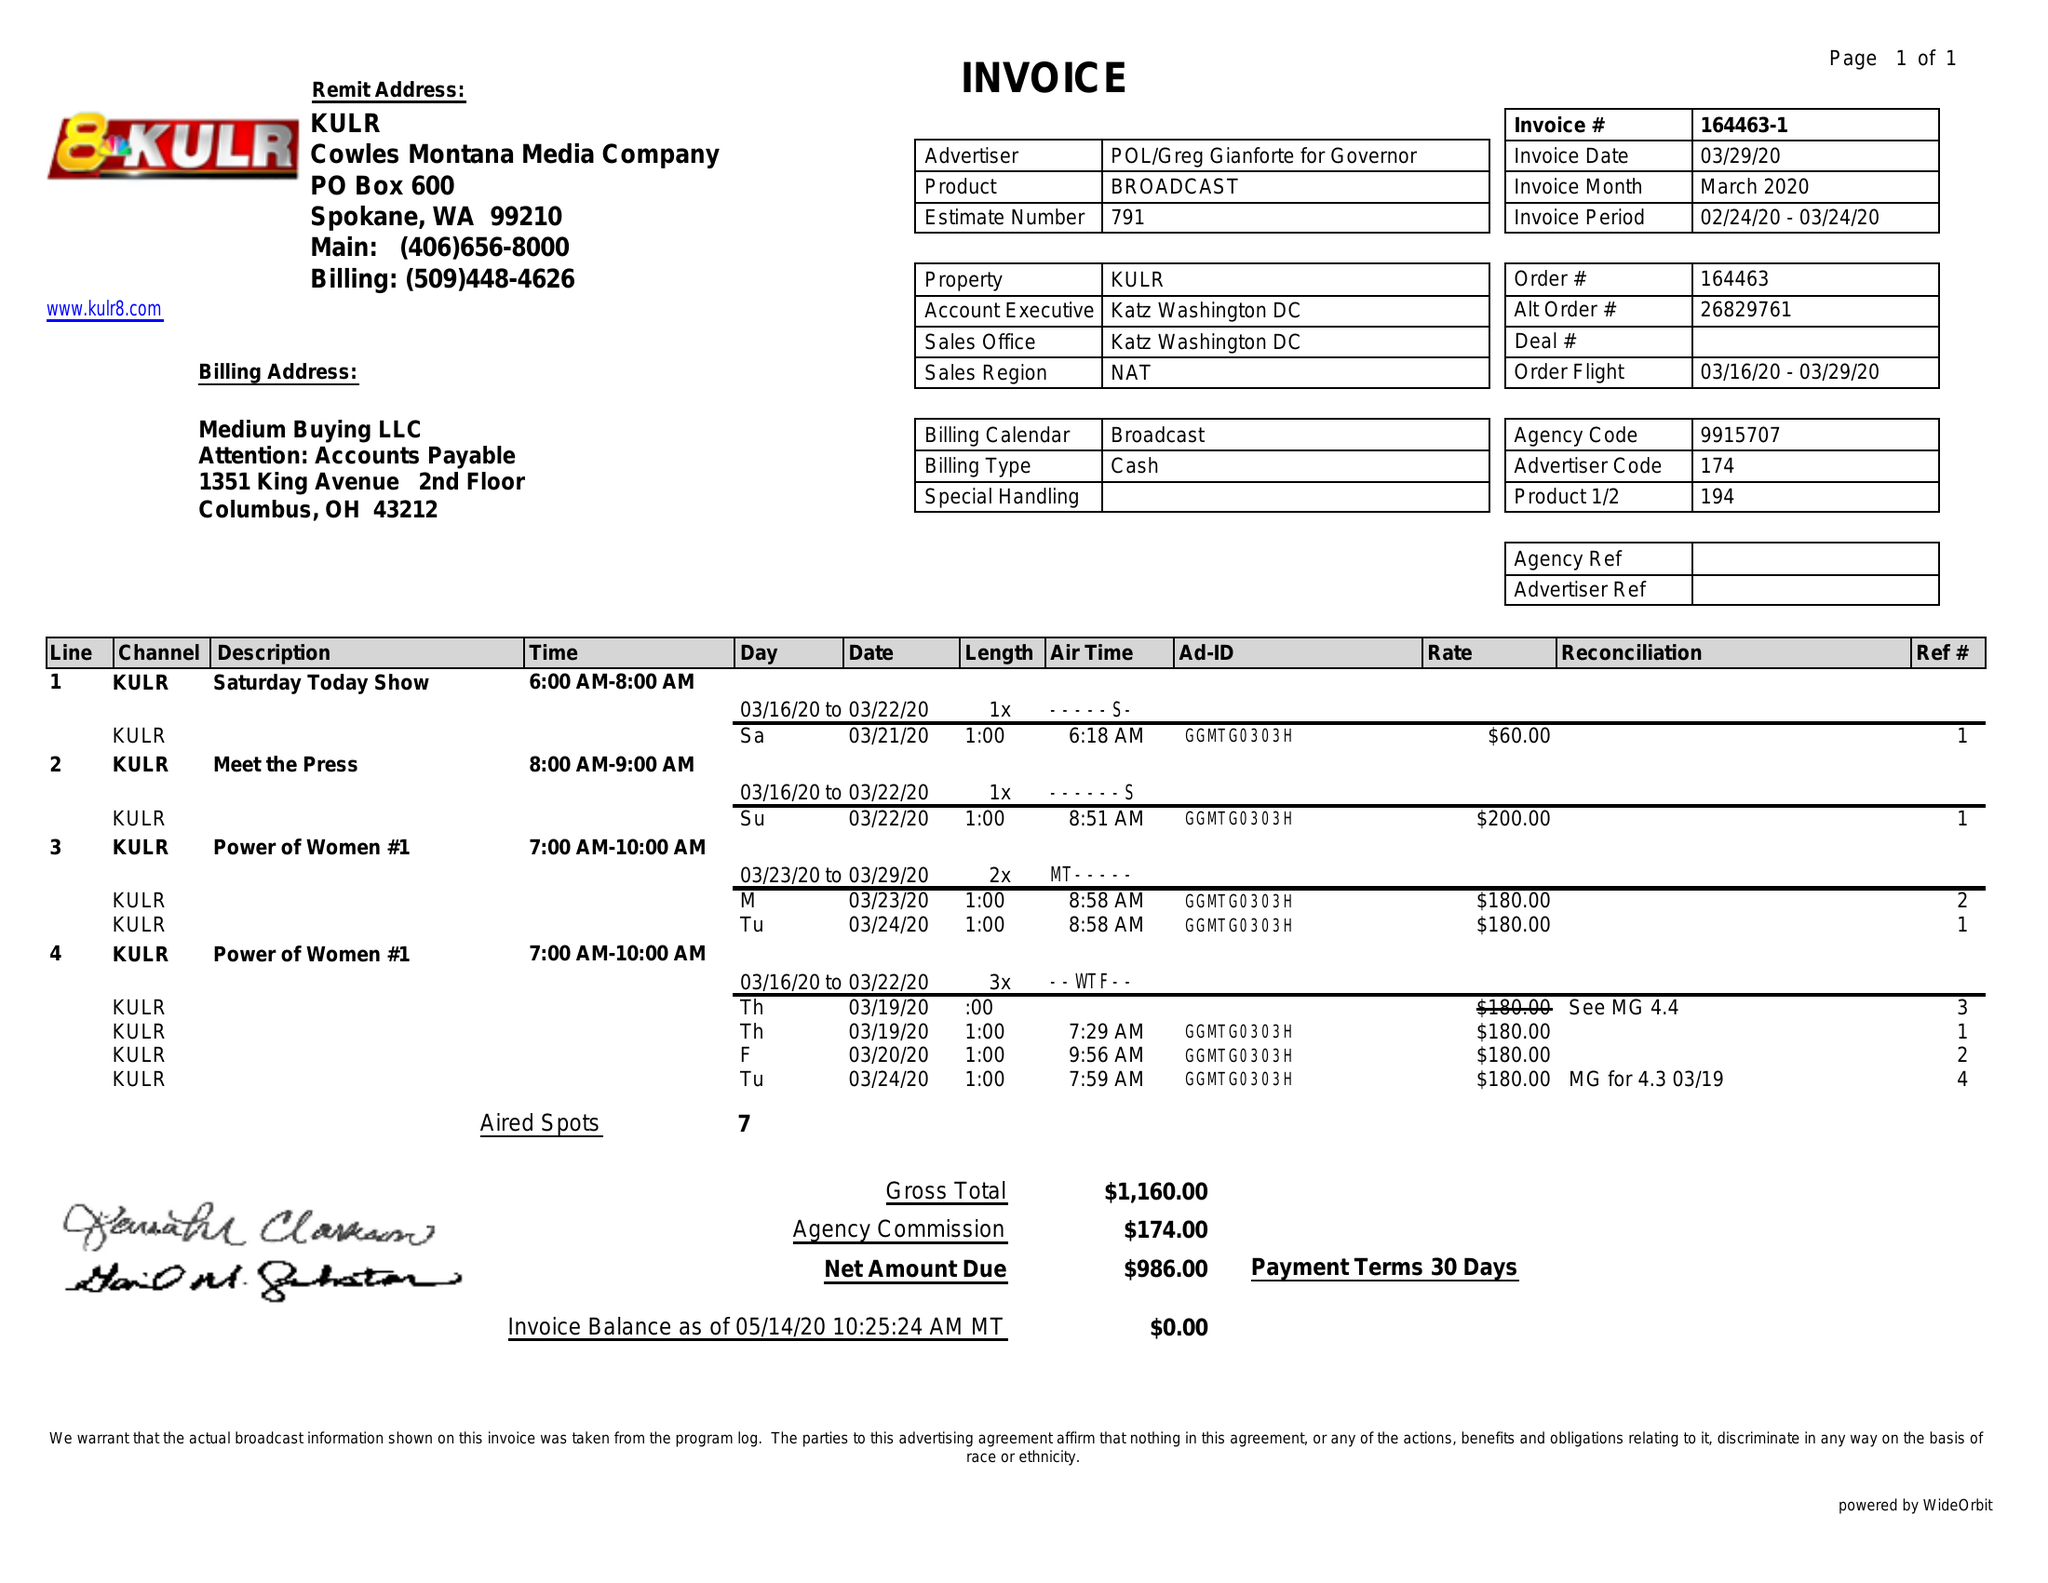What is the value for the gross_amount?
Answer the question using a single word or phrase. 1160.00 